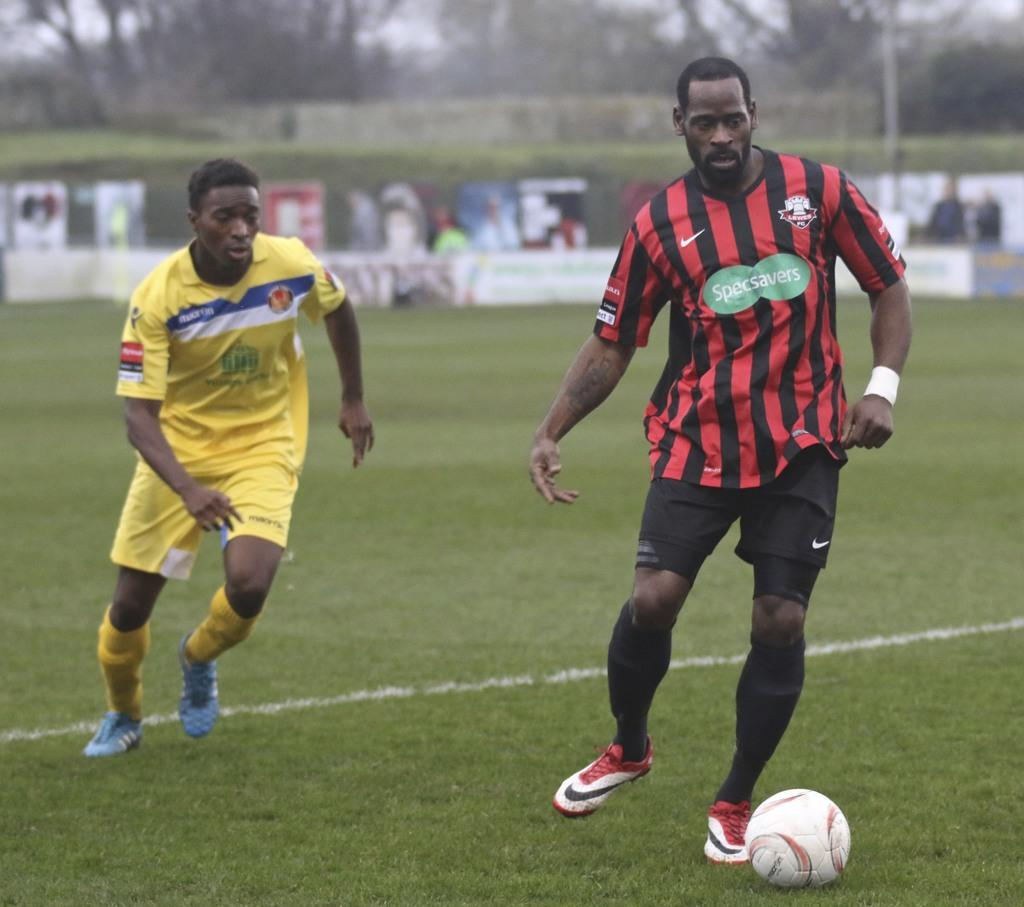<image>
Give a short and clear explanation of the subsequent image. A soccer player for SpecSavers is dribbling the ball. 